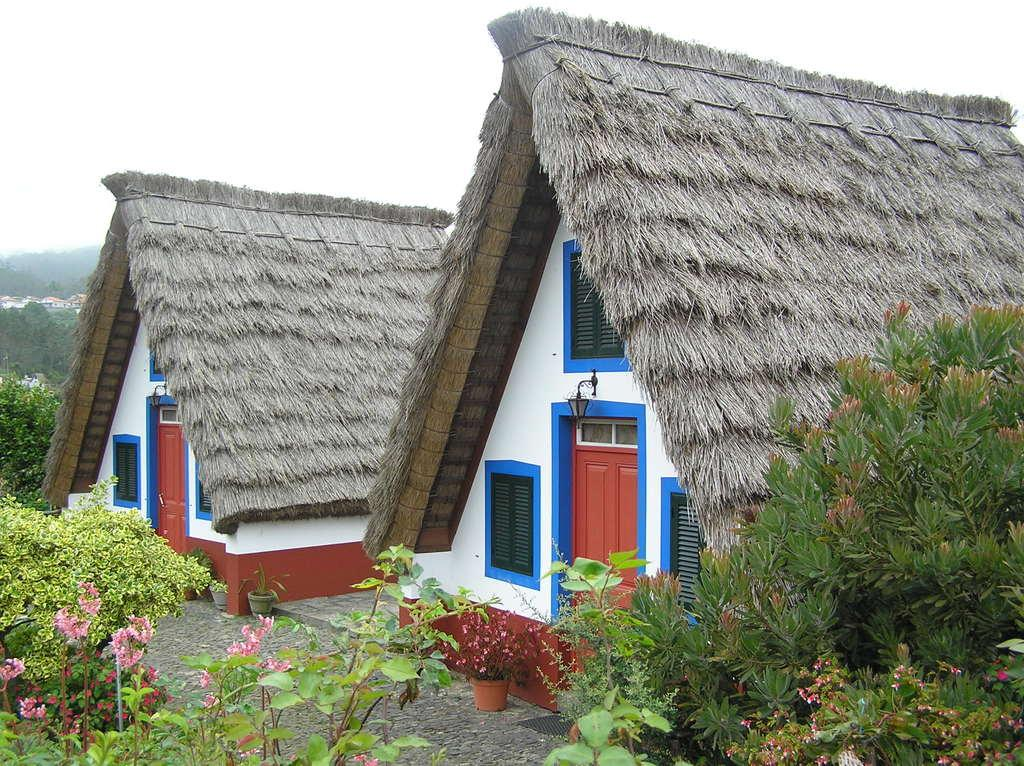What type of structures can be seen in the image? There are houses in the image. What objects are present near the houses? There are flower pots and plants in the image. What can be seen in the background of the image? There are trees and the sky visible in the background of the image. How many kittens are playing with the worm in the image? There are no kittens or worms present in the image. 